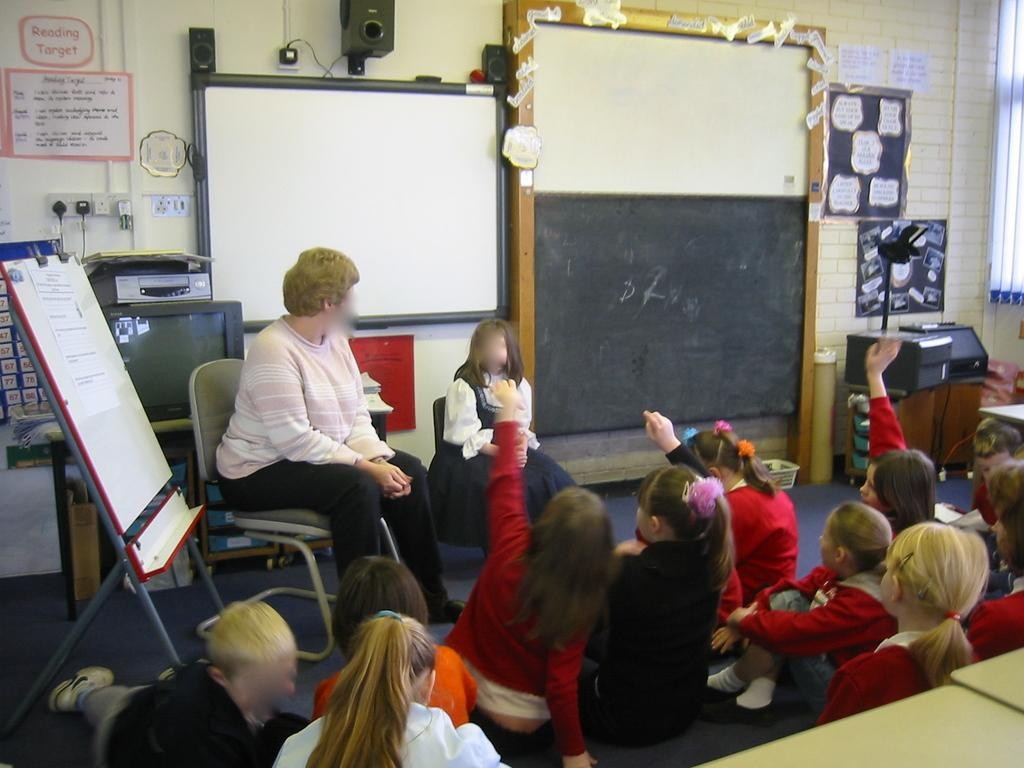What are the persons in the image doing? The persons in the image are sitting on the floor and chairs. What is the board with a stand used for in the image? The board with a stand is likely used for displaying or presenting something, as it is accompanied by a whiteboard. What can be seen on the wall in the image? Posters are present on the wall in the image. What is the color of the floor in the image? The floor is visible in the image, but the color is not specified in the provided facts. What type of tax is being discussed on the whiteboard in the image? There is no mention of tax or any discussion about it in the image. Can you tell me how many grapes are on the table in the image? There is no table or grapes present in the image. 